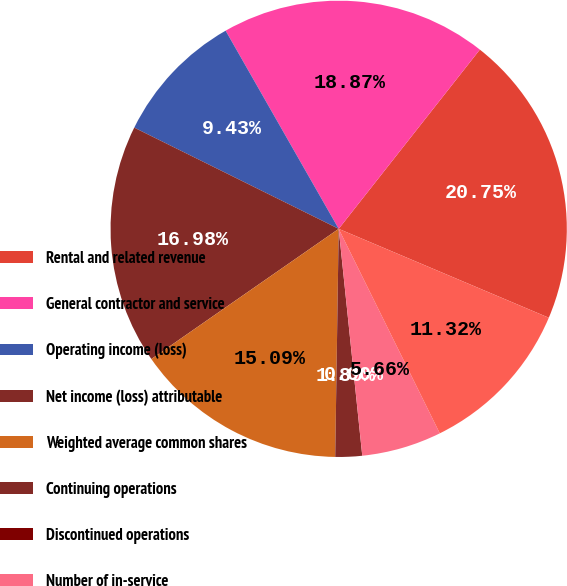Convert chart to OTSL. <chart><loc_0><loc_0><loc_500><loc_500><pie_chart><fcel>Rental and related revenue<fcel>General contractor and service<fcel>Operating income (loss)<fcel>Net income (loss) attributable<fcel>Weighted average common shares<fcel>Continuing operations<fcel>Discontinued operations<fcel>Number of in-service<fcel>In-service consolidated square<nl><fcel>20.75%<fcel>18.87%<fcel>9.43%<fcel>16.98%<fcel>15.09%<fcel>1.89%<fcel>0.0%<fcel>5.66%<fcel>11.32%<nl></chart> 